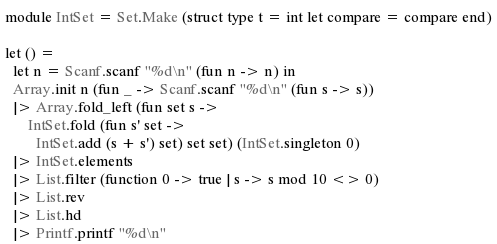Convert code to text. <code><loc_0><loc_0><loc_500><loc_500><_OCaml_>module IntSet = Set.Make (struct type t = int let compare = compare end)

let () =
  let n = Scanf.scanf "%d\n" (fun n -> n) in
  Array.init n (fun _ -> Scanf.scanf "%d\n" (fun s -> s))
  |> Array.fold_left (fun set s ->
      IntSet.fold (fun s' set ->
        IntSet.add (s + s') set) set set) (IntSet.singleton 0)
  |> IntSet.elements
  |> List.filter (function 0 -> true | s -> s mod 10 <> 0)
  |> List.rev
  |> List.hd
  |> Printf.printf "%d\n"
</code> 